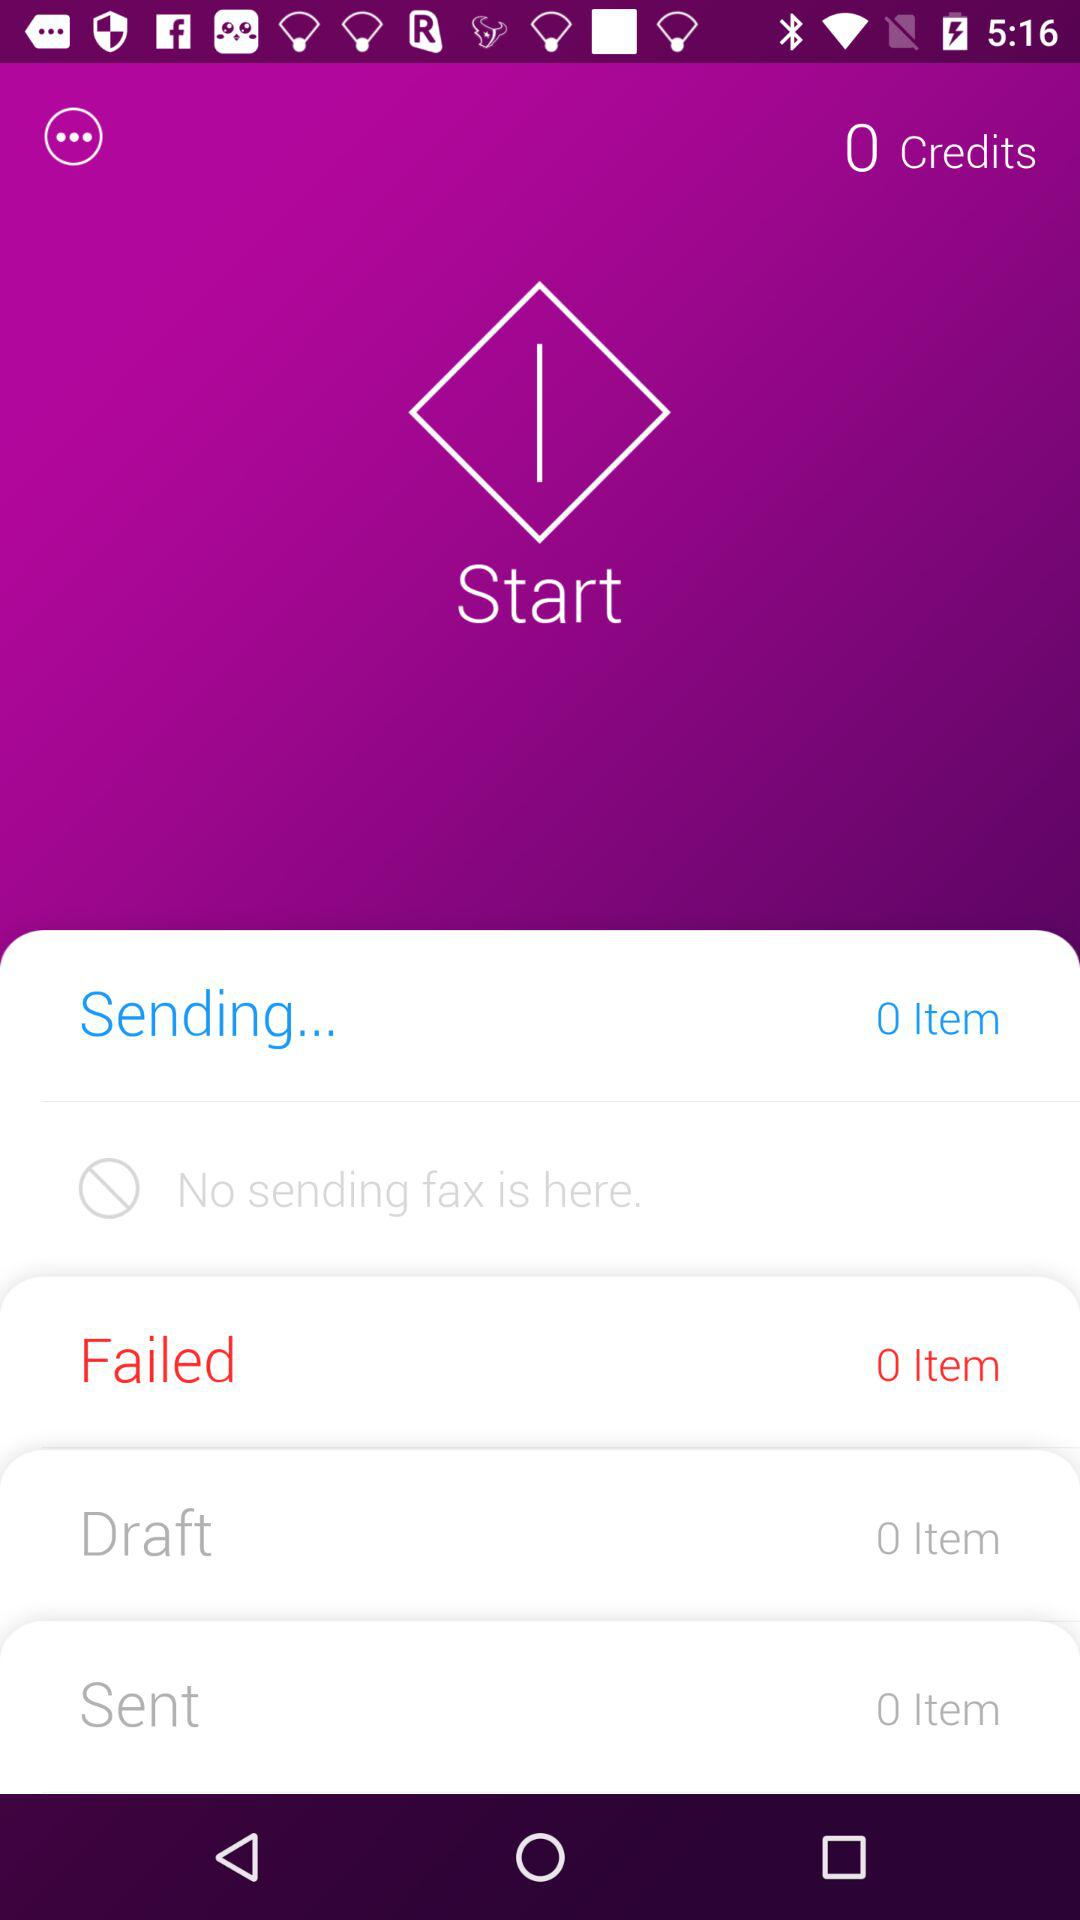How many items are being sent? The number of items that are being sent is 0. 